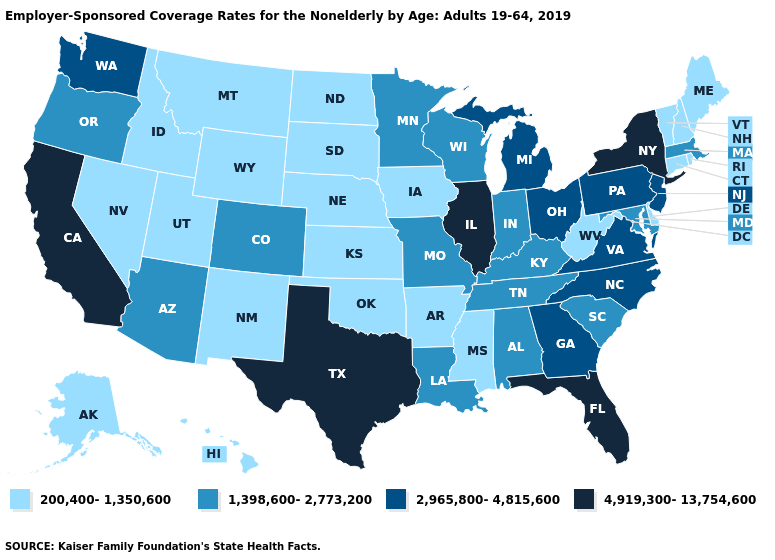Name the states that have a value in the range 1,398,600-2,773,200?
Quick response, please. Alabama, Arizona, Colorado, Indiana, Kentucky, Louisiana, Maryland, Massachusetts, Minnesota, Missouri, Oregon, South Carolina, Tennessee, Wisconsin. What is the value of Michigan?
Write a very short answer. 2,965,800-4,815,600. What is the value of Idaho?
Concise answer only. 200,400-1,350,600. What is the lowest value in the USA?
Answer briefly. 200,400-1,350,600. Name the states that have a value in the range 1,398,600-2,773,200?
Write a very short answer. Alabama, Arizona, Colorado, Indiana, Kentucky, Louisiana, Maryland, Massachusetts, Minnesota, Missouri, Oregon, South Carolina, Tennessee, Wisconsin. Name the states that have a value in the range 200,400-1,350,600?
Give a very brief answer. Alaska, Arkansas, Connecticut, Delaware, Hawaii, Idaho, Iowa, Kansas, Maine, Mississippi, Montana, Nebraska, Nevada, New Hampshire, New Mexico, North Dakota, Oklahoma, Rhode Island, South Dakota, Utah, Vermont, West Virginia, Wyoming. Which states have the lowest value in the USA?
Be succinct. Alaska, Arkansas, Connecticut, Delaware, Hawaii, Idaho, Iowa, Kansas, Maine, Mississippi, Montana, Nebraska, Nevada, New Hampshire, New Mexico, North Dakota, Oklahoma, Rhode Island, South Dakota, Utah, Vermont, West Virginia, Wyoming. Does Iowa have the highest value in the USA?
Short answer required. No. Does Florida have the lowest value in the USA?
Give a very brief answer. No. What is the value of California?
Concise answer only. 4,919,300-13,754,600. Which states have the lowest value in the MidWest?
Concise answer only. Iowa, Kansas, Nebraska, North Dakota, South Dakota. Name the states that have a value in the range 2,965,800-4,815,600?
Concise answer only. Georgia, Michigan, New Jersey, North Carolina, Ohio, Pennsylvania, Virginia, Washington. What is the lowest value in states that border Maryland?
Be succinct. 200,400-1,350,600. What is the lowest value in states that border West Virginia?
Write a very short answer. 1,398,600-2,773,200. Name the states that have a value in the range 1,398,600-2,773,200?
Give a very brief answer. Alabama, Arizona, Colorado, Indiana, Kentucky, Louisiana, Maryland, Massachusetts, Minnesota, Missouri, Oregon, South Carolina, Tennessee, Wisconsin. 